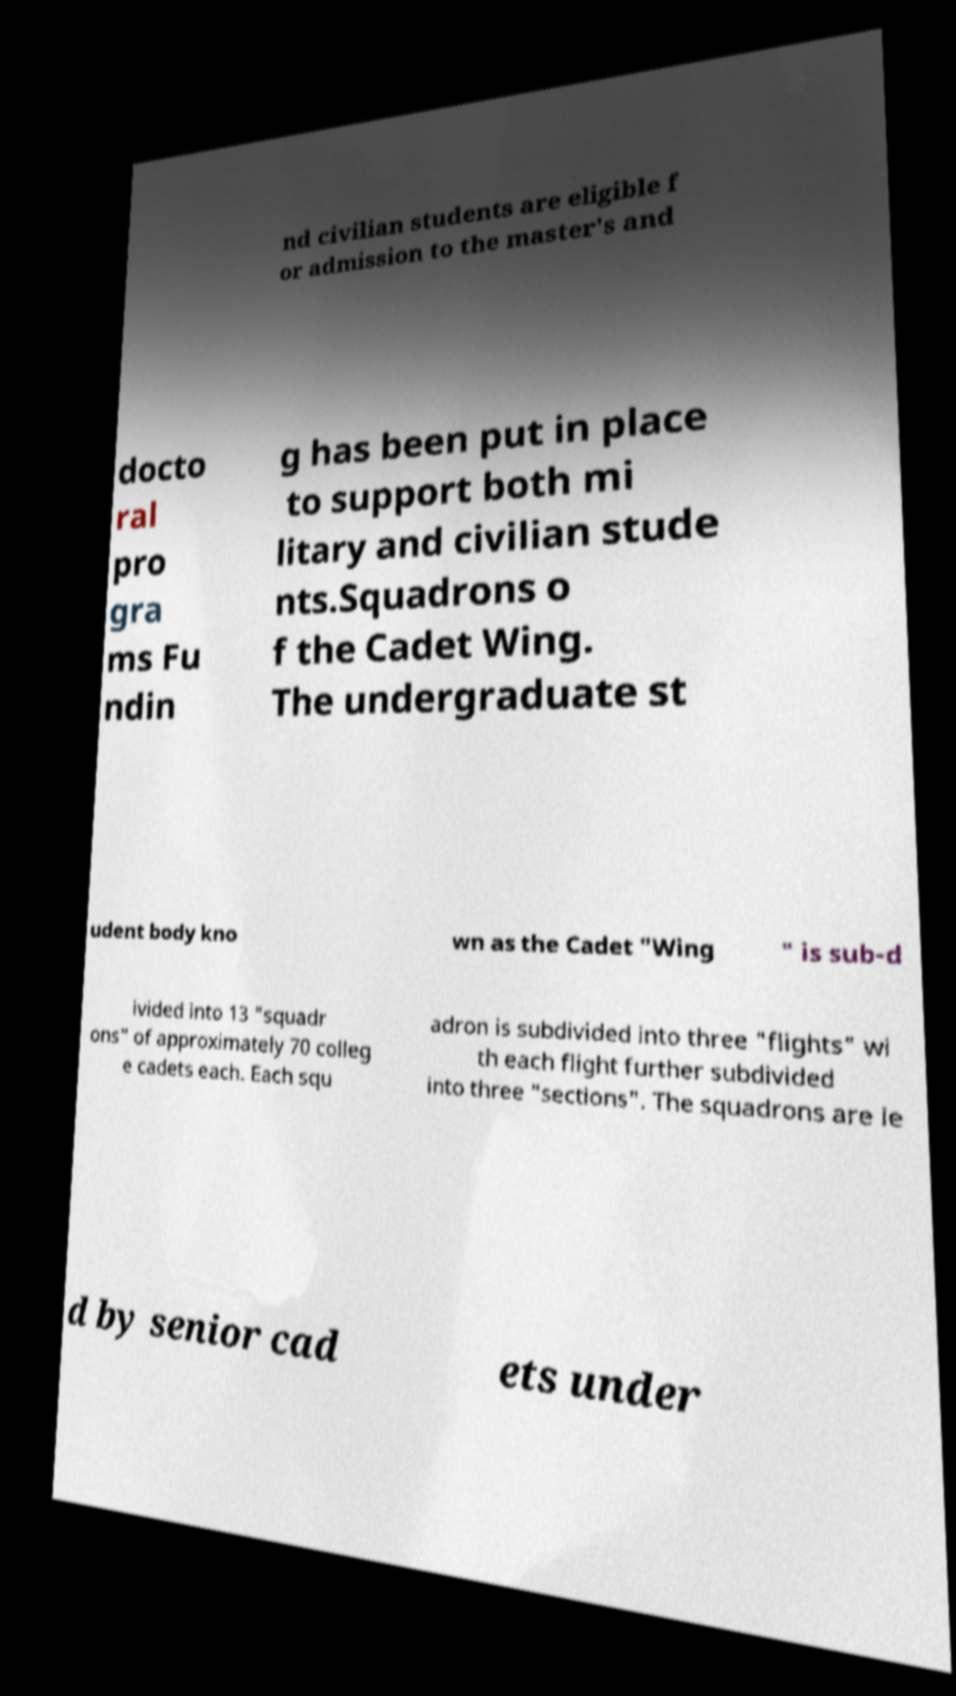Please identify and transcribe the text found in this image. nd civilian students are eligible f or admission to the master's and docto ral pro gra ms Fu ndin g has been put in place to support both mi litary and civilian stude nts.Squadrons o f the Cadet Wing. The undergraduate st udent body kno wn as the Cadet "Wing " is sub-d ivided into 13 "squadr ons" of approximately 70 colleg e cadets each. Each squ adron is subdivided into three "flights" wi th each flight further subdivided into three "sections". The squadrons are le d by senior cad ets under 